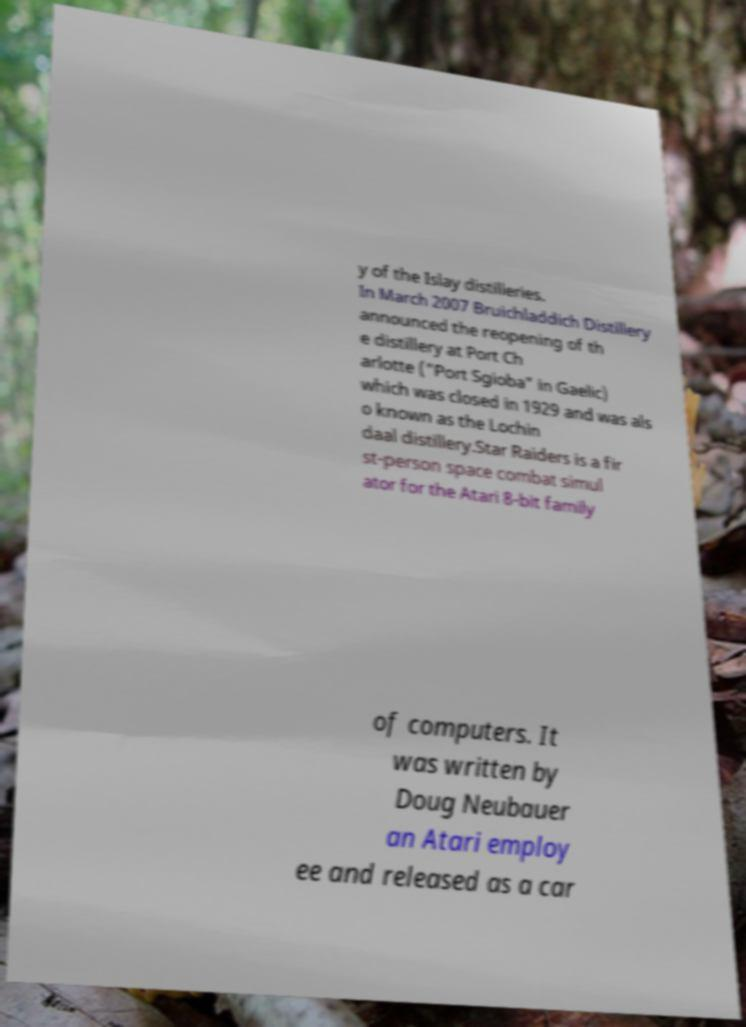What messages or text are displayed in this image? I need them in a readable, typed format. y of the Islay distilleries. In March 2007 Bruichladdich Distillery announced the reopening of th e distillery at Port Ch arlotte ("Port Sgioba" in Gaelic) which was closed in 1929 and was als o known as the Lochin daal distillery.Star Raiders is a fir st-person space combat simul ator for the Atari 8-bit family of computers. It was written by Doug Neubauer an Atari employ ee and released as a car 